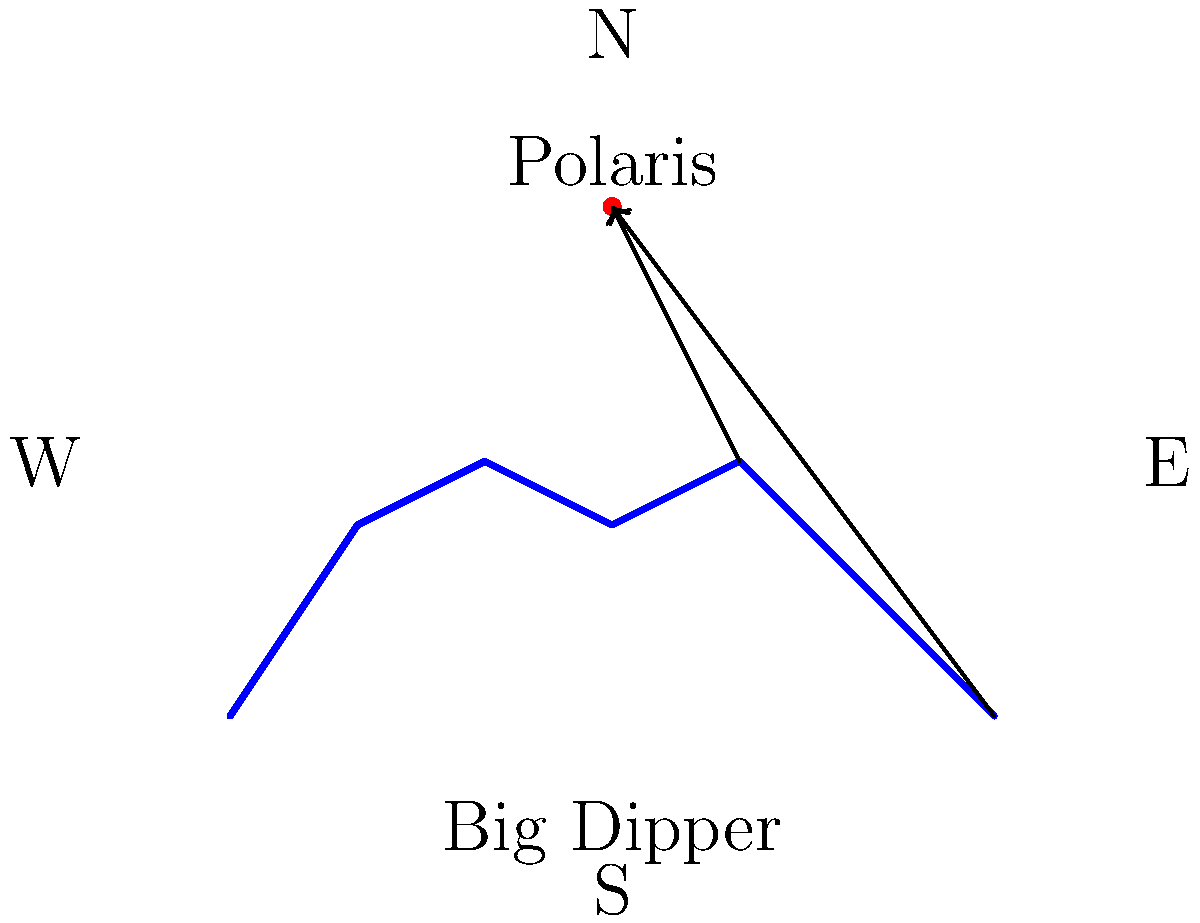As you observe the night sky from Olivet College in Michigan, you notice the Big Dipper constellation. How can you use this constellation to locate Polaris, the North Star, and why is this significant for determining direction? 1. The Big Dipper, part of the Ursa Major constellation, is visible year-round from Olivet College due to its circumpolar nature in the Northern Hemisphere.

2. To locate Polaris using the Big Dipper:
   a) Identify the two stars at the front edge of the Big Dipper's bowl (farthest from the handle).
   b) Draw an imaginary line connecting these two stars and extend it about 5 times the distance between them.
   c) This line will lead directly to Polaris, the brightest star in the constellation Ursa Minor (Little Dipper).

3. Polaris is significant because:
   a) It remains nearly stationary in the night sky, always indicating the direction of true north.
   b) Its altitude above the horizon closely corresponds to the observer's latitude. Olivet College is at approximately 42.4°N latitude, so Polaris would appear about 42.4° above the northern horizon.

4. Historically, this method of finding Polaris has been crucial for:
   a) Navigation, especially for sailors and early explorers.
   b) Orientation for travelers and cartographers.
   c) Determining latitude for geographical and astronomical purposes.

5. In the context of Olivet College's history (founded in 1844), this celestial navigation technique would have been well-known and potentially taught as part of practical education in astronomy or geography.
Answer: Use the two front stars of the Big Dipper's bowl to locate Polaris, which indicates true north and helps determine direction and latitude. 